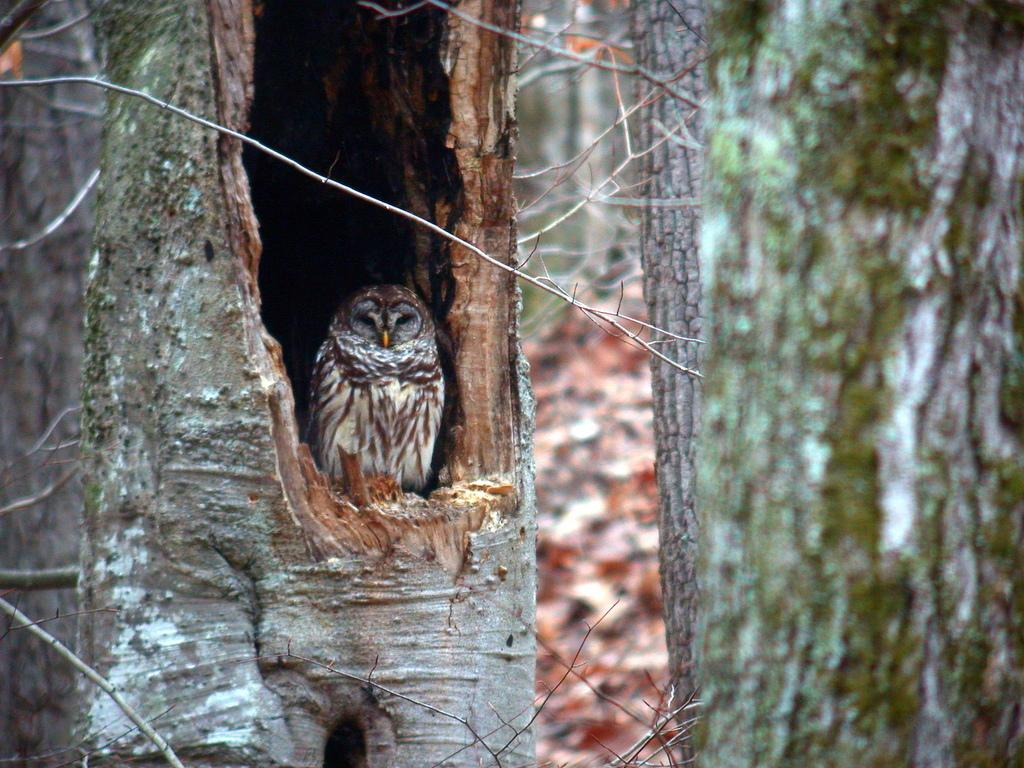What is the main subject of the image? There is a bird in the center of the image. What can be seen in the background of the image? There are trees and dry leaves in the background of the image. What noise does the bird make in the image? The image is still, so we cannot hear any noise made by the bird. 